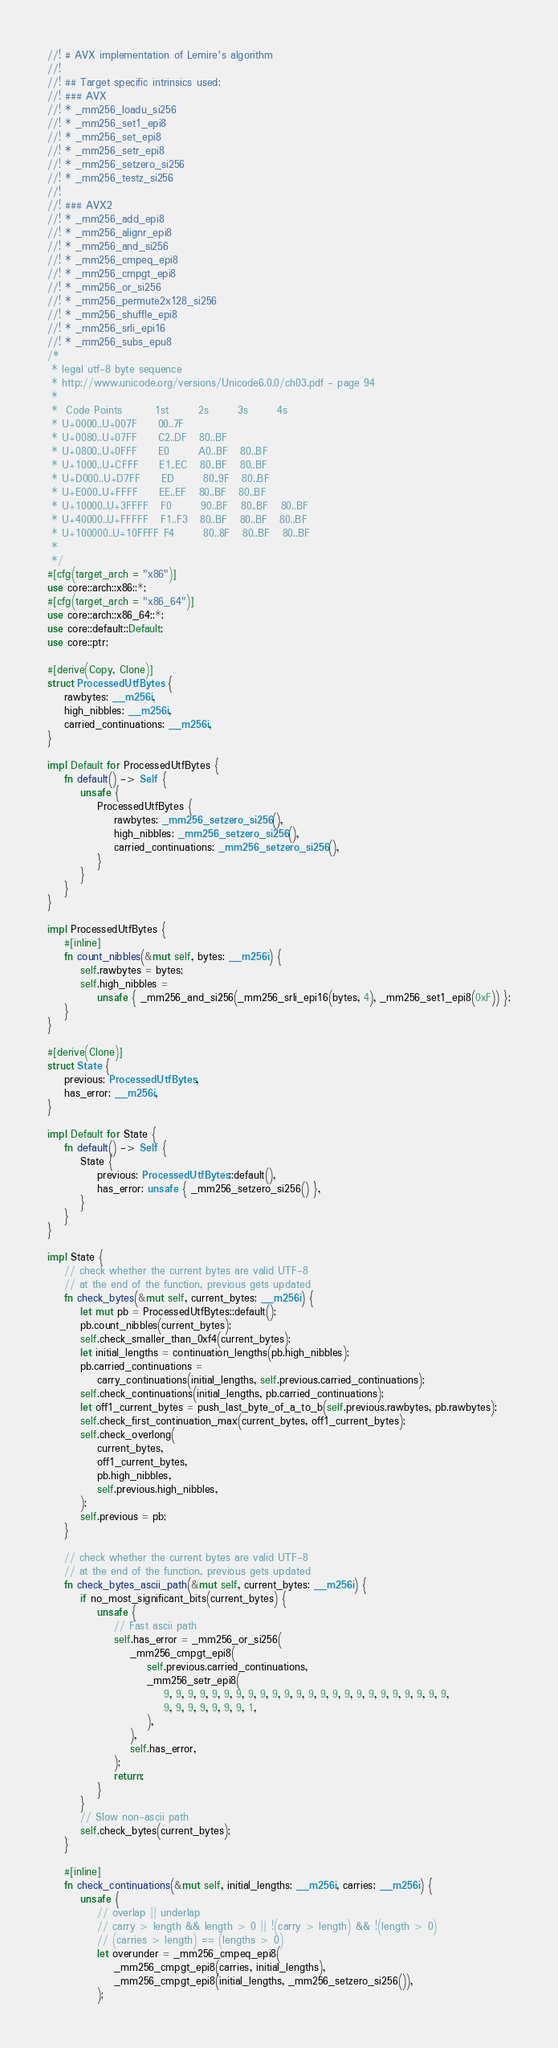<code> <loc_0><loc_0><loc_500><loc_500><_Rust_>//! # AVX implementation of Lemire's algorithm
//!
//! ## Target specific intrinsics used:
//! ### AVX
//! * _mm256_loadu_si256
//! * _mm256_set1_epi8
//! * _mm256_set_epi8
//! * _mm256_setr_epi8
//! * _mm256_setzero_si256
//! * _mm256_testz_si256
//!
//! ### AVX2
//! * _mm256_add_epi8
//! * _mm256_alignr_epi8
//! * _mm256_and_si256
//! * _mm256_cmpeq_epi8
//! * _mm256_cmpgt_epi8
//! * _mm256_or_si256
//! * _mm256_permute2x128_si256
//! * _mm256_shuffle_epi8
//! * _mm256_srli_epi16
//! * _mm256_subs_epu8
/*
 * legal utf-8 byte sequence
 * http://www.unicode.org/versions/Unicode6.0.0/ch03.pdf - page 94
 *
 *  Code Points        1st       2s       3s       4s
 * U+0000..U+007F     00..7F
 * U+0080..U+07FF     C2..DF   80..BF
 * U+0800..U+0FFF     E0       A0..BF   80..BF
 * U+1000..U+CFFF     E1..EC   80..BF   80..BF
 * U+D000..U+D7FF     ED       80..9F   80..BF
 * U+E000..U+FFFF     EE..EF   80..BF   80..BF
 * U+10000..U+3FFFF   F0       90..BF   80..BF   80..BF
 * U+40000..U+FFFFF   F1..F3   80..BF   80..BF   80..BF
 * U+100000..U+10FFFF F4       80..8F   80..BF   80..BF
 *
 */
#[cfg(target_arch = "x86")]
use core::arch::x86::*;
#[cfg(target_arch = "x86_64")]
use core::arch::x86_64::*;
use core::default::Default;
use core::ptr;

#[derive(Copy, Clone)]
struct ProcessedUtfBytes {
    rawbytes: __m256i,
    high_nibbles: __m256i,
    carried_continuations: __m256i,
}

impl Default for ProcessedUtfBytes {
    fn default() -> Self {
        unsafe {
            ProcessedUtfBytes {
                rawbytes: _mm256_setzero_si256(),
                high_nibbles: _mm256_setzero_si256(),
                carried_continuations: _mm256_setzero_si256(),
            }
        }
    }
}

impl ProcessedUtfBytes {
    #[inline]
    fn count_nibbles(&mut self, bytes: __m256i) {
        self.rawbytes = bytes;
        self.high_nibbles =
            unsafe { _mm256_and_si256(_mm256_srli_epi16(bytes, 4), _mm256_set1_epi8(0xF)) };
    }
}

#[derive(Clone)]
struct State {
    previous: ProcessedUtfBytes,
    has_error: __m256i,
}

impl Default for State {
    fn default() -> Self {
        State {
            previous: ProcessedUtfBytes::default(),
            has_error: unsafe { _mm256_setzero_si256() },
        }
    }
}

impl State {
    // check whether the current bytes are valid UTF-8
    // at the end of the function, previous gets updated
    fn check_bytes(&mut self, current_bytes: __m256i) {
        let mut pb = ProcessedUtfBytes::default();
        pb.count_nibbles(current_bytes);
        self.check_smaller_than_0xf4(current_bytes);
        let initial_lengths = continuation_lengths(pb.high_nibbles);
        pb.carried_continuations =
            carry_continuations(initial_lengths, self.previous.carried_continuations);
        self.check_continuations(initial_lengths, pb.carried_continuations);
        let off1_current_bytes = push_last_byte_of_a_to_b(self.previous.rawbytes, pb.rawbytes);
        self.check_first_continuation_max(current_bytes, off1_current_bytes);
        self.check_overlong(
            current_bytes,
            off1_current_bytes,
            pb.high_nibbles,
            self.previous.high_nibbles,
        );
        self.previous = pb;
    }

    // check whether the current bytes are valid UTF-8
    // at the end of the function, previous gets updated
    fn check_bytes_ascii_path(&mut self, current_bytes: __m256i) {
        if no_most_significant_bits(current_bytes) {
            unsafe {
                // Fast ascii path
                self.has_error = _mm256_or_si256(
                    _mm256_cmpgt_epi8(
                        self.previous.carried_continuations,
                        _mm256_setr_epi8(
                            9, 9, 9, 9, 9, 9, 9, 9, 9, 9, 9, 9, 9, 9, 9, 9, 9, 9, 9, 9, 9, 9, 9, 9,
                            9, 9, 9, 9, 9, 9, 9, 1,
                        ),
                    ),
                    self.has_error,
                );
                return;
            }
        }
        // Slow non-ascii path
        self.check_bytes(current_bytes);
    }

    #[inline]
    fn check_continuations(&mut self, initial_lengths: __m256i, carries: __m256i) {
        unsafe {
            // overlap || underlap
            // carry > length && length > 0 || !(carry > length) && !(length > 0)
            // (carries > length) == (lengths > 0)
            let overunder = _mm256_cmpeq_epi8(
                _mm256_cmpgt_epi8(carries, initial_lengths),
                _mm256_cmpgt_epi8(initial_lengths, _mm256_setzero_si256()),
            );</code> 